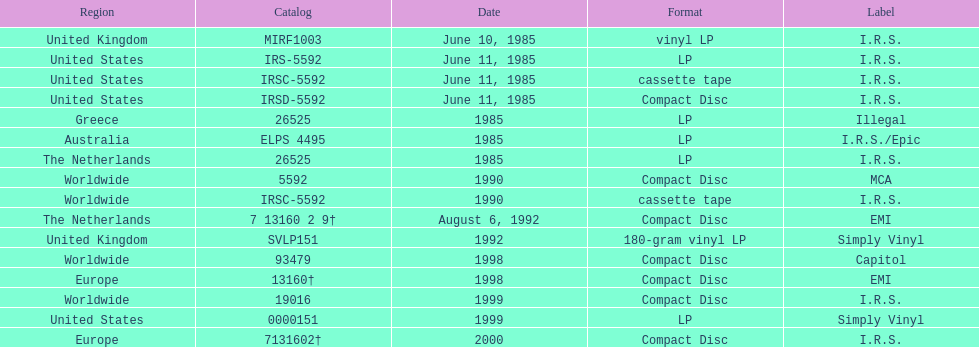Which dates were their releases by fables of the reconstruction? June 10, 1985, June 11, 1985, June 11, 1985, June 11, 1985, 1985, 1985, 1985, 1990, 1990, August 6, 1992, 1992, 1998, 1998, 1999, 1999, 2000. Which of these are in 1985? June 10, 1985, June 11, 1985, June 11, 1985, June 11, 1985, 1985, 1985, 1985. What regions were there releases on these dates? United Kingdom, United States, United States, United States, Greece, Australia, The Netherlands. Which of these are not greece? United Kingdom, United States, United States, United States, Australia, The Netherlands. Which of these regions have two labels listed? Australia. 